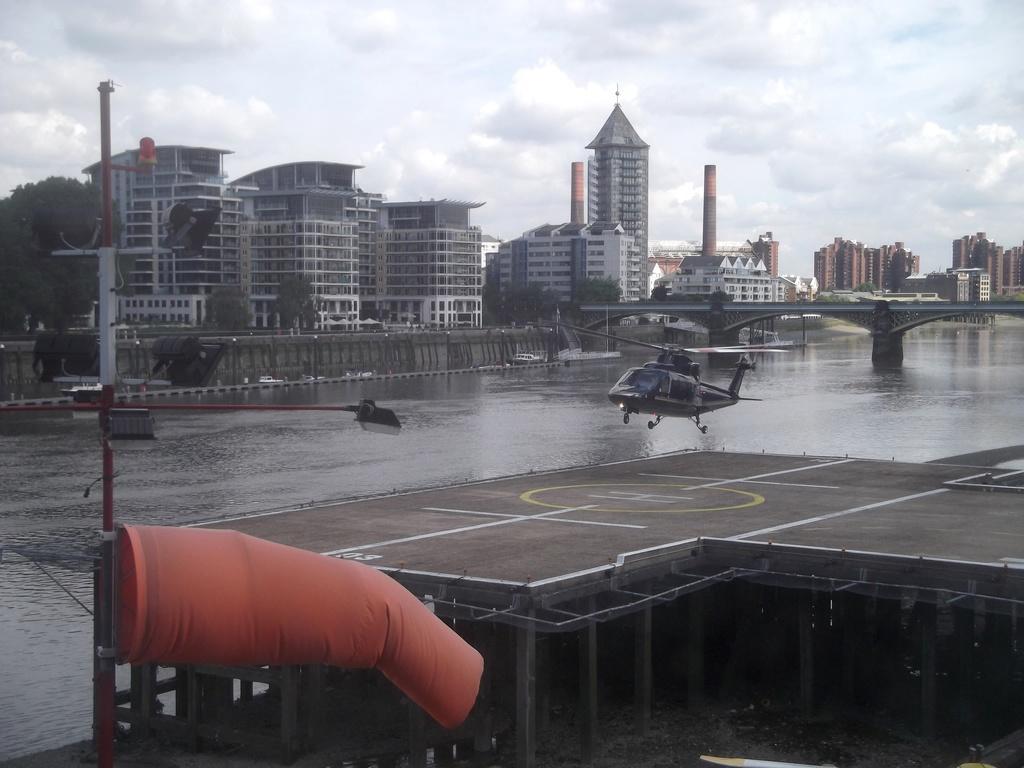Please provide a concise description of this image. In this picture we can see a helicopter and a helipad here, at the bottom there is water, we can see a pole here, in the background there are some buildings, we can see a tree here, there is the sky at the top of the picture, we can see a bridge here. 